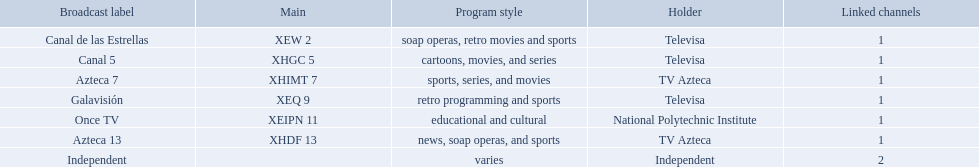What station shows cartoons? Canal 5. What station shows soap operas? Canal de las Estrellas. What station shows sports? Azteca 7. Which owner only owns one network? National Polytechnic Institute, Independent. Of those, what is the network name? Once TV, Independent. Of those, which programming type is educational and cultural? Once TV. 